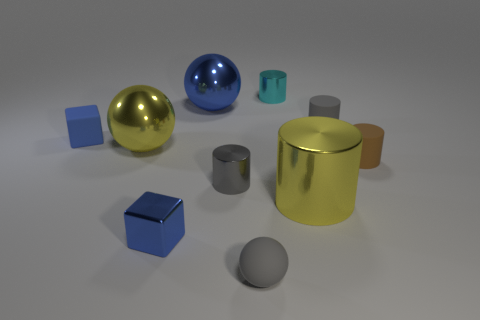Subtract all brown cylinders. How many cylinders are left? 4 Subtract all tiny gray rubber cylinders. How many cylinders are left? 4 Subtract all blue cylinders. Subtract all cyan spheres. How many cylinders are left? 5 Subtract all spheres. How many objects are left? 7 Add 3 large cylinders. How many large cylinders are left? 4 Add 2 red metal cylinders. How many red metal cylinders exist? 2 Subtract 0 red cylinders. How many objects are left? 10 Subtract all cyan cylinders. Subtract all large spheres. How many objects are left? 7 